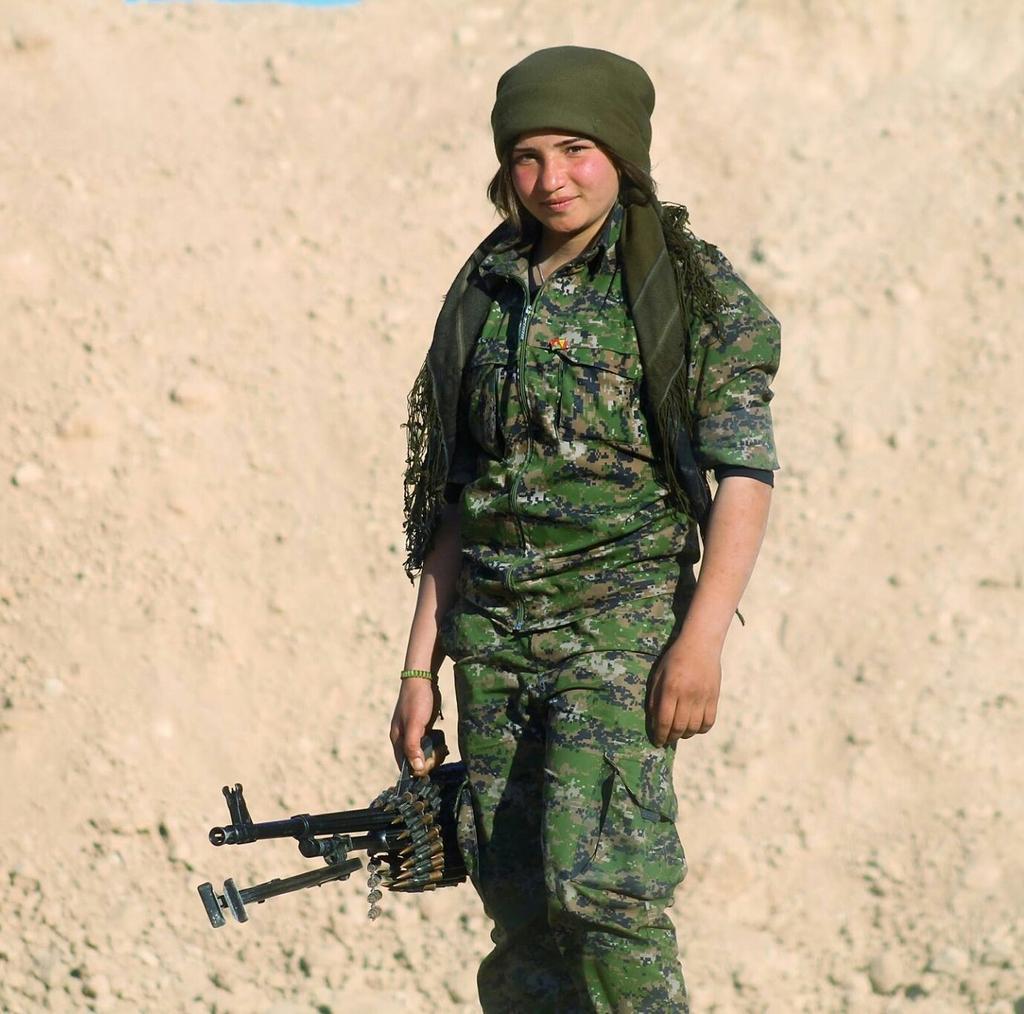Please provide a concise description of this image. In this image I can see the person with the military dress and holding the weapon. And I can see the cream color background 